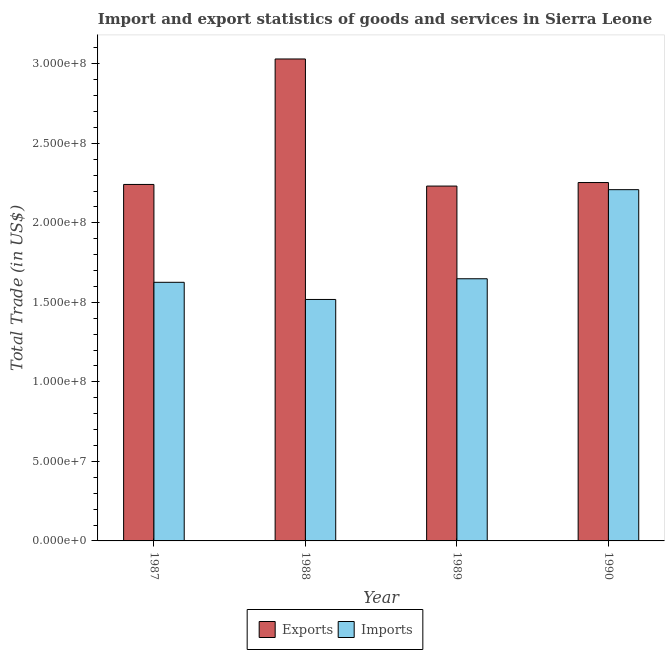How many different coloured bars are there?
Your answer should be very brief. 2. How many groups of bars are there?
Offer a terse response. 4. How many bars are there on the 1st tick from the left?
Provide a succinct answer. 2. How many bars are there on the 3rd tick from the right?
Provide a succinct answer. 2. In how many cases, is the number of bars for a given year not equal to the number of legend labels?
Ensure brevity in your answer.  0. What is the imports of goods and services in 1990?
Give a very brief answer. 2.21e+08. Across all years, what is the maximum export of goods and services?
Provide a succinct answer. 3.03e+08. Across all years, what is the minimum imports of goods and services?
Offer a very short reply. 1.52e+08. In which year was the imports of goods and services minimum?
Provide a short and direct response. 1988. What is the total imports of goods and services in the graph?
Offer a very short reply. 7.00e+08. What is the difference between the export of goods and services in 1988 and that in 1989?
Your response must be concise. 7.99e+07. What is the difference between the imports of goods and services in 1990 and the export of goods and services in 1989?
Your response must be concise. 5.60e+07. What is the average export of goods and services per year?
Ensure brevity in your answer.  2.44e+08. In the year 1987, what is the difference between the imports of goods and services and export of goods and services?
Provide a short and direct response. 0. In how many years, is the imports of goods and services greater than 90000000 US$?
Give a very brief answer. 4. What is the ratio of the imports of goods and services in 1989 to that in 1990?
Make the answer very short. 0.75. What is the difference between the highest and the second highest imports of goods and services?
Keep it short and to the point. 5.60e+07. What is the difference between the highest and the lowest export of goods and services?
Make the answer very short. 7.99e+07. In how many years, is the imports of goods and services greater than the average imports of goods and services taken over all years?
Give a very brief answer. 1. What does the 2nd bar from the left in 1989 represents?
Your answer should be compact. Imports. What does the 2nd bar from the right in 1989 represents?
Your answer should be compact. Exports. How many years are there in the graph?
Provide a short and direct response. 4. Are the values on the major ticks of Y-axis written in scientific E-notation?
Your answer should be compact. Yes. What is the title of the graph?
Keep it short and to the point. Import and export statistics of goods and services in Sierra Leone. What is the label or title of the X-axis?
Keep it short and to the point. Year. What is the label or title of the Y-axis?
Give a very brief answer. Total Trade (in US$). What is the Total Trade (in US$) in Exports in 1987?
Ensure brevity in your answer.  2.24e+08. What is the Total Trade (in US$) in Imports in 1987?
Provide a succinct answer. 1.63e+08. What is the Total Trade (in US$) in Exports in 1988?
Keep it short and to the point. 3.03e+08. What is the Total Trade (in US$) of Imports in 1988?
Provide a succinct answer. 1.52e+08. What is the Total Trade (in US$) in Exports in 1989?
Make the answer very short. 2.23e+08. What is the Total Trade (in US$) in Imports in 1989?
Your answer should be compact. 1.65e+08. What is the Total Trade (in US$) in Exports in 1990?
Your response must be concise. 2.25e+08. What is the Total Trade (in US$) of Imports in 1990?
Provide a short and direct response. 2.21e+08. Across all years, what is the maximum Total Trade (in US$) in Exports?
Provide a short and direct response. 3.03e+08. Across all years, what is the maximum Total Trade (in US$) of Imports?
Provide a short and direct response. 2.21e+08. Across all years, what is the minimum Total Trade (in US$) in Exports?
Make the answer very short. 2.23e+08. Across all years, what is the minimum Total Trade (in US$) of Imports?
Offer a very short reply. 1.52e+08. What is the total Total Trade (in US$) of Exports in the graph?
Give a very brief answer. 9.76e+08. What is the total Total Trade (in US$) in Imports in the graph?
Your response must be concise. 7.00e+08. What is the difference between the Total Trade (in US$) in Exports in 1987 and that in 1988?
Give a very brief answer. -7.89e+07. What is the difference between the Total Trade (in US$) in Imports in 1987 and that in 1988?
Your response must be concise. 1.08e+07. What is the difference between the Total Trade (in US$) of Exports in 1987 and that in 1989?
Offer a terse response. 1.02e+06. What is the difference between the Total Trade (in US$) of Imports in 1987 and that in 1989?
Provide a succinct answer. -2.24e+06. What is the difference between the Total Trade (in US$) of Exports in 1987 and that in 1990?
Provide a succinct answer. -1.19e+06. What is the difference between the Total Trade (in US$) of Imports in 1987 and that in 1990?
Give a very brief answer. -5.83e+07. What is the difference between the Total Trade (in US$) in Exports in 1988 and that in 1989?
Your answer should be very brief. 7.99e+07. What is the difference between the Total Trade (in US$) in Imports in 1988 and that in 1989?
Keep it short and to the point. -1.30e+07. What is the difference between the Total Trade (in US$) of Exports in 1988 and that in 1990?
Provide a short and direct response. 7.77e+07. What is the difference between the Total Trade (in US$) of Imports in 1988 and that in 1990?
Your answer should be compact. -6.90e+07. What is the difference between the Total Trade (in US$) in Exports in 1989 and that in 1990?
Keep it short and to the point. -2.22e+06. What is the difference between the Total Trade (in US$) in Imports in 1989 and that in 1990?
Ensure brevity in your answer.  -5.60e+07. What is the difference between the Total Trade (in US$) in Exports in 1987 and the Total Trade (in US$) in Imports in 1988?
Make the answer very short. 7.23e+07. What is the difference between the Total Trade (in US$) in Exports in 1987 and the Total Trade (in US$) in Imports in 1989?
Your response must be concise. 5.93e+07. What is the difference between the Total Trade (in US$) in Exports in 1987 and the Total Trade (in US$) in Imports in 1990?
Keep it short and to the point. 3.28e+06. What is the difference between the Total Trade (in US$) of Exports in 1988 and the Total Trade (in US$) of Imports in 1989?
Make the answer very short. 1.38e+08. What is the difference between the Total Trade (in US$) in Exports in 1988 and the Total Trade (in US$) in Imports in 1990?
Give a very brief answer. 8.22e+07. What is the difference between the Total Trade (in US$) of Exports in 1989 and the Total Trade (in US$) of Imports in 1990?
Provide a short and direct response. 2.26e+06. What is the average Total Trade (in US$) of Exports per year?
Offer a terse response. 2.44e+08. What is the average Total Trade (in US$) of Imports per year?
Offer a very short reply. 1.75e+08. In the year 1987, what is the difference between the Total Trade (in US$) of Exports and Total Trade (in US$) of Imports?
Your answer should be very brief. 6.15e+07. In the year 1988, what is the difference between the Total Trade (in US$) in Exports and Total Trade (in US$) in Imports?
Ensure brevity in your answer.  1.51e+08. In the year 1989, what is the difference between the Total Trade (in US$) of Exports and Total Trade (in US$) of Imports?
Ensure brevity in your answer.  5.83e+07. In the year 1990, what is the difference between the Total Trade (in US$) of Exports and Total Trade (in US$) of Imports?
Your answer should be very brief. 4.48e+06. What is the ratio of the Total Trade (in US$) in Exports in 1987 to that in 1988?
Make the answer very short. 0.74. What is the ratio of the Total Trade (in US$) in Imports in 1987 to that in 1988?
Ensure brevity in your answer.  1.07. What is the ratio of the Total Trade (in US$) of Exports in 1987 to that in 1989?
Ensure brevity in your answer.  1. What is the ratio of the Total Trade (in US$) in Imports in 1987 to that in 1989?
Provide a succinct answer. 0.99. What is the ratio of the Total Trade (in US$) in Exports in 1987 to that in 1990?
Provide a succinct answer. 0.99. What is the ratio of the Total Trade (in US$) of Imports in 1987 to that in 1990?
Provide a short and direct response. 0.74. What is the ratio of the Total Trade (in US$) of Exports in 1988 to that in 1989?
Your answer should be very brief. 1.36. What is the ratio of the Total Trade (in US$) in Imports in 1988 to that in 1989?
Provide a short and direct response. 0.92. What is the ratio of the Total Trade (in US$) in Exports in 1988 to that in 1990?
Your response must be concise. 1.34. What is the ratio of the Total Trade (in US$) of Imports in 1988 to that in 1990?
Make the answer very short. 0.69. What is the ratio of the Total Trade (in US$) of Exports in 1989 to that in 1990?
Your response must be concise. 0.99. What is the ratio of the Total Trade (in US$) in Imports in 1989 to that in 1990?
Offer a very short reply. 0.75. What is the difference between the highest and the second highest Total Trade (in US$) in Exports?
Give a very brief answer. 7.77e+07. What is the difference between the highest and the second highest Total Trade (in US$) of Imports?
Offer a terse response. 5.60e+07. What is the difference between the highest and the lowest Total Trade (in US$) in Exports?
Give a very brief answer. 7.99e+07. What is the difference between the highest and the lowest Total Trade (in US$) in Imports?
Your answer should be compact. 6.90e+07. 